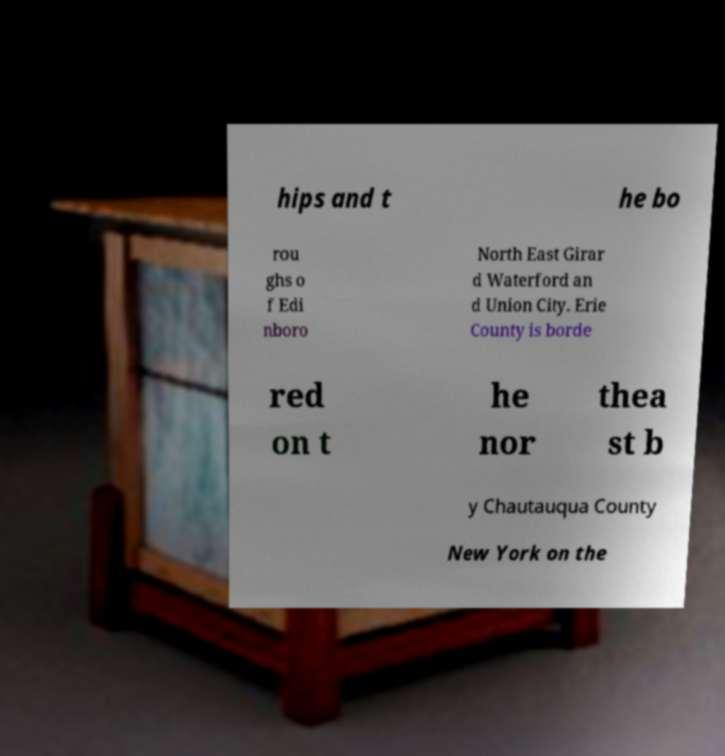What messages or text are displayed in this image? I need them in a readable, typed format. hips and t he bo rou ghs o f Edi nboro North East Girar d Waterford an d Union City. Erie County is borde red on t he nor thea st b y Chautauqua County New York on the 